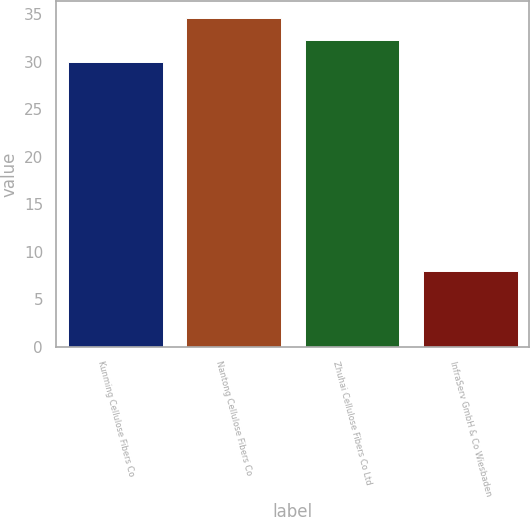Convert chart. <chart><loc_0><loc_0><loc_500><loc_500><bar_chart><fcel>Kunming Cellulose Fibers Co<fcel>Nantong Cellulose Fibers Co<fcel>Zhuhai Cellulose Fibers Co Ltd<fcel>InfraServ GmbH & Co Wiesbaden<nl><fcel>30<fcel>34.6<fcel>32.3<fcel>8<nl></chart> 